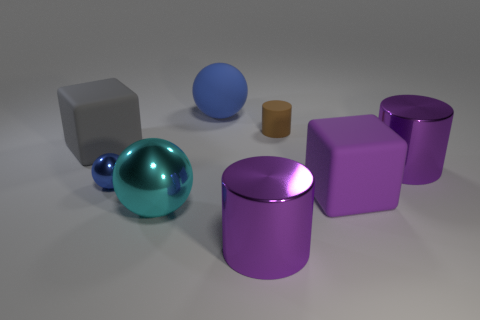The cyan thing that is the same size as the purple matte object is what shape? The cyan object, which shares a similar size with the purple matte one, is a sphere. 